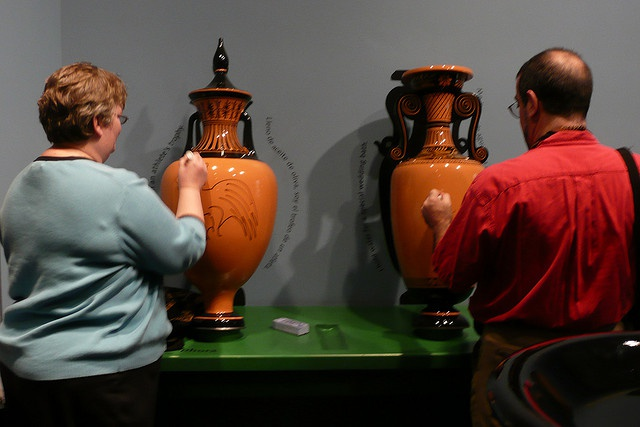Describe the objects in this image and their specific colors. I can see people in gray, black, and darkgray tones, people in gray, black, maroon, brown, and red tones, vase in gray, black, maroon, red, and brown tones, and vase in gray, black, maroon, red, and brown tones in this image. 